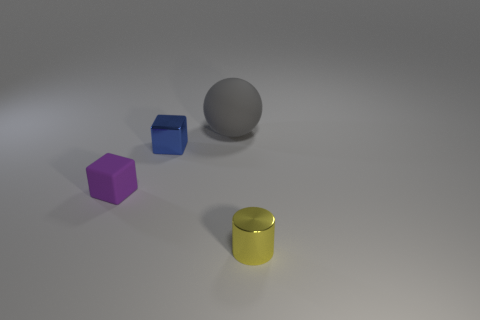Add 1 rubber spheres. How many objects exist? 5 Subtract all cylinders. How many objects are left? 3 Subtract 0 purple balls. How many objects are left? 4 Subtract all small cyan shiny cylinders. Subtract all yellow metallic objects. How many objects are left? 3 Add 1 yellow metallic cylinders. How many yellow metallic cylinders are left? 2 Add 1 tiny blue metallic blocks. How many tiny blue metallic blocks exist? 2 